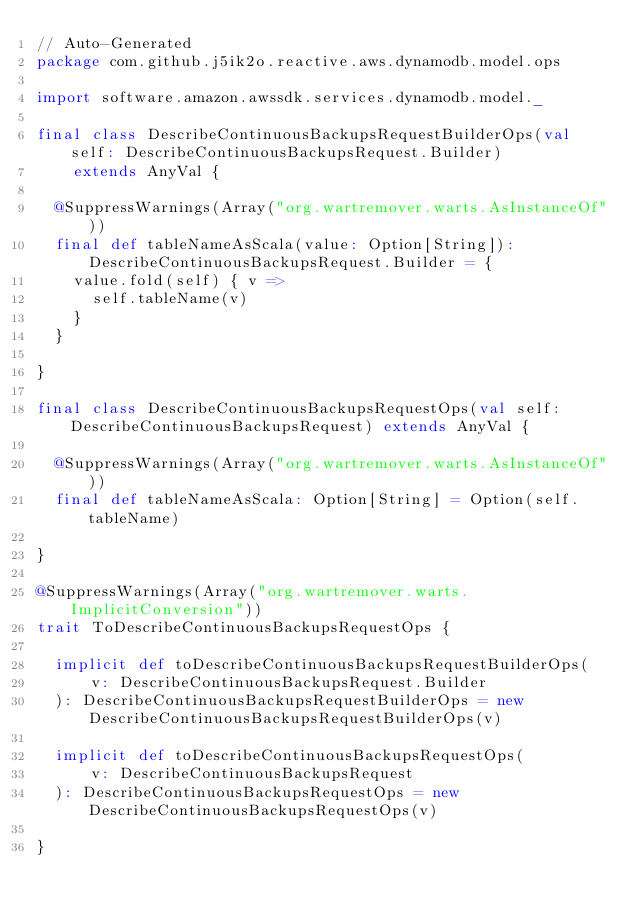Convert code to text. <code><loc_0><loc_0><loc_500><loc_500><_Scala_>// Auto-Generated
package com.github.j5ik2o.reactive.aws.dynamodb.model.ops

import software.amazon.awssdk.services.dynamodb.model._

final class DescribeContinuousBackupsRequestBuilderOps(val self: DescribeContinuousBackupsRequest.Builder)
    extends AnyVal {

  @SuppressWarnings(Array("org.wartremover.warts.AsInstanceOf"))
  final def tableNameAsScala(value: Option[String]): DescribeContinuousBackupsRequest.Builder = {
    value.fold(self) { v =>
      self.tableName(v)
    }
  }

}

final class DescribeContinuousBackupsRequestOps(val self: DescribeContinuousBackupsRequest) extends AnyVal {

  @SuppressWarnings(Array("org.wartremover.warts.AsInstanceOf"))
  final def tableNameAsScala: Option[String] = Option(self.tableName)

}

@SuppressWarnings(Array("org.wartremover.warts.ImplicitConversion"))
trait ToDescribeContinuousBackupsRequestOps {

  implicit def toDescribeContinuousBackupsRequestBuilderOps(
      v: DescribeContinuousBackupsRequest.Builder
  ): DescribeContinuousBackupsRequestBuilderOps = new DescribeContinuousBackupsRequestBuilderOps(v)

  implicit def toDescribeContinuousBackupsRequestOps(
      v: DescribeContinuousBackupsRequest
  ): DescribeContinuousBackupsRequestOps = new DescribeContinuousBackupsRequestOps(v)

}
</code> 